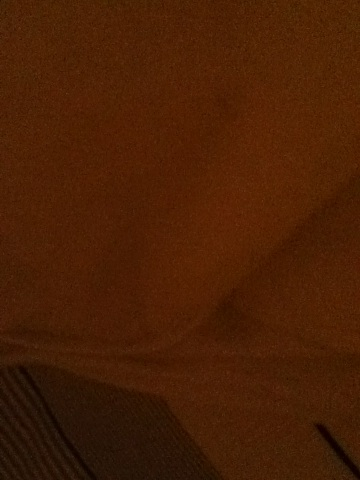What might be the source of light in this picture? The light source in this picture appears to be minimal and diffuse. It could be coming from a small, indirect source such as a bedside lamp or light filtering through a closed curtain. What could this fabric be used for? This fabric appears to be soft and perhaps thick, suggesting it could be used for items like blankets, curtains, or upholstery. The pattern might indicate it is part of a home décor element meant to add texture and warmth to a space. Imagine if this fabric could talk. What story would it tell? If this fabric could talk, it might share tales of cozy evenings spent wrapped around loved ones, offering warmth and comfort. It could recount the sunlight filtering through during quiet mornings, or the gentle whispers from the room it adorns. Perhaps it has been part of family gatherings or witnessed moments of solitude and reflection. Describe a potential scene where this fabric plays a significant role. In a cozy, dimly lit living room, this fabric, now a beautifully textured throw blanket, drapes elegantly over the back of a plush armchair. The soft, warm glow of a nearby fireplace flickers across the room, casting dancing shadows on the walls. The blanket has been there for numerous family game nights, cradling the laughter and joy of children and parents alike. On quiet Sunday mornings, a person sits in the armchair with a cup of tea, the blanket folded neatly in their lap, enjoying the serene silence of a sleeping house. Could you describe a shorter scenario where the fabric is significant? A child wraps themselves in this cozy fabric, it being their favorite blanket, during a story time session with their grandparent. 